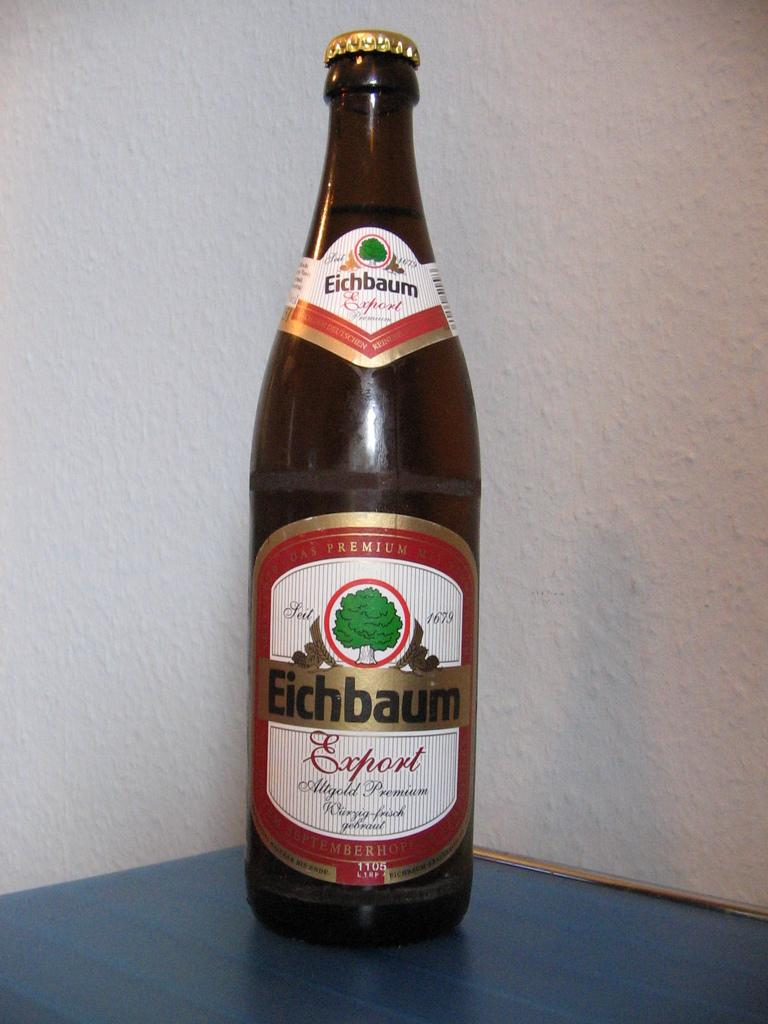Provide a one-sentence caption for the provided image. A bottle of Eichbaum Export against a white walll. 